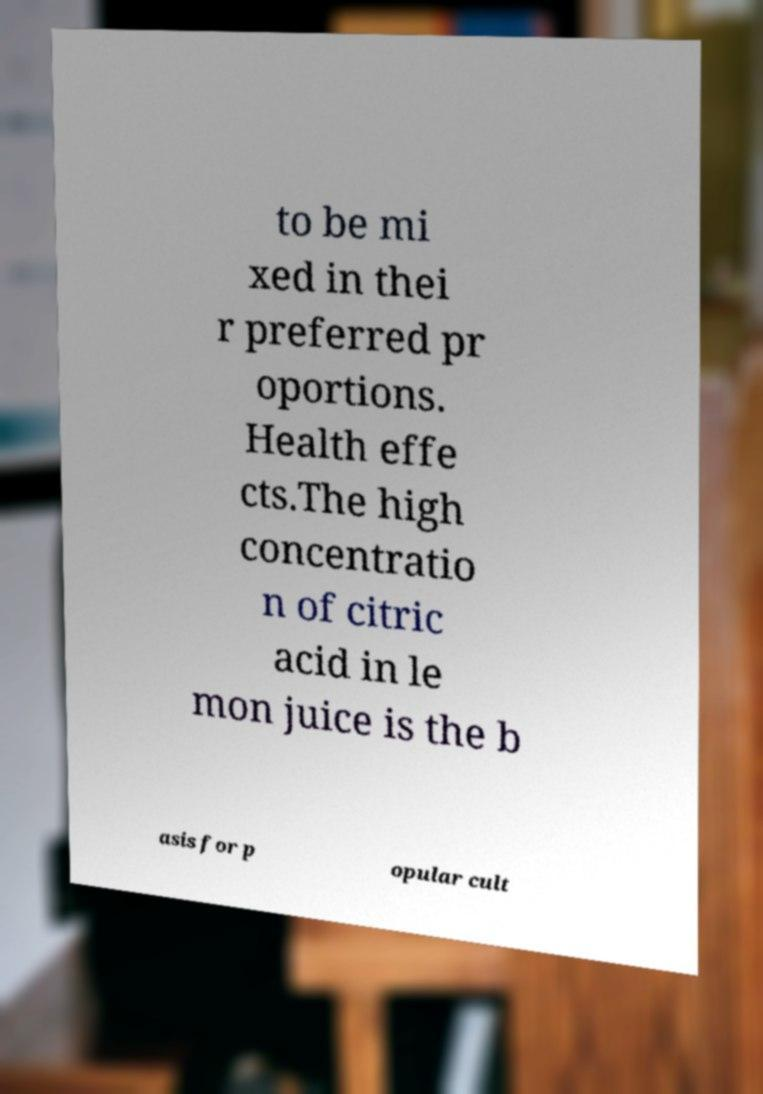Could you extract and type out the text from this image? to be mi xed in thei r preferred pr oportions. Health effe cts.The high concentratio n of citric acid in le mon juice is the b asis for p opular cult 